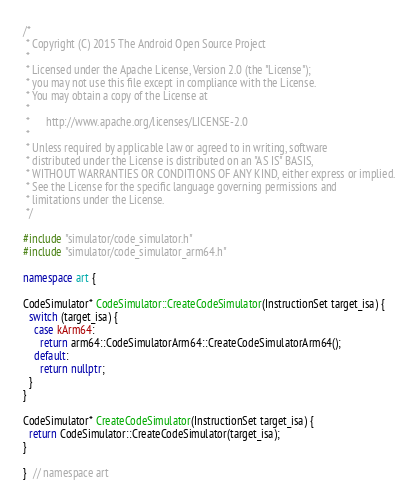Convert code to text. <code><loc_0><loc_0><loc_500><loc_500><_C++_>/*
 * Copyright (C) 2015 The Android Open Source Project
 *
 * Licensed under the Apache License, Version 2.0 (the "License");
 * you may not use this file except in compliance with the License.
 * You may obtain a copy of the License at
 *
 *      http://www.apache.org/licenses/LICENSE-2.0
 *
 * Unless required by applicable law or agreed to in writing, software
 * distributed under the License is distributed on an "AS IS" BASIS,
 * WITHOUT WARRANTIES OR CONDITIONS OF ANY KIND, either express or implied.
 * See the License for the specific language governing permissions and
 * limitations under the License.
 */

#include "simulator/code_simulator.h"
#include "simulator/code_simulator_arm64.h"

namespace art {

CodeSimulator* CodeSimulator::CreateCodeSimulator(InstructionSet target_isa) {
  switch (target_isa) {
    case kArm64:
      return arm64::CodeSimulatorArm64::CreateCodeSimulatorArm64();
    default:
      return nullptr;
  }
}

CodeSimulator* CreateCodeSimulator(InstructionSet target_isa) {
  return CodeSimulator::CreateCodeSimulator(target_isa);
}

}  // namespace art
</code> 